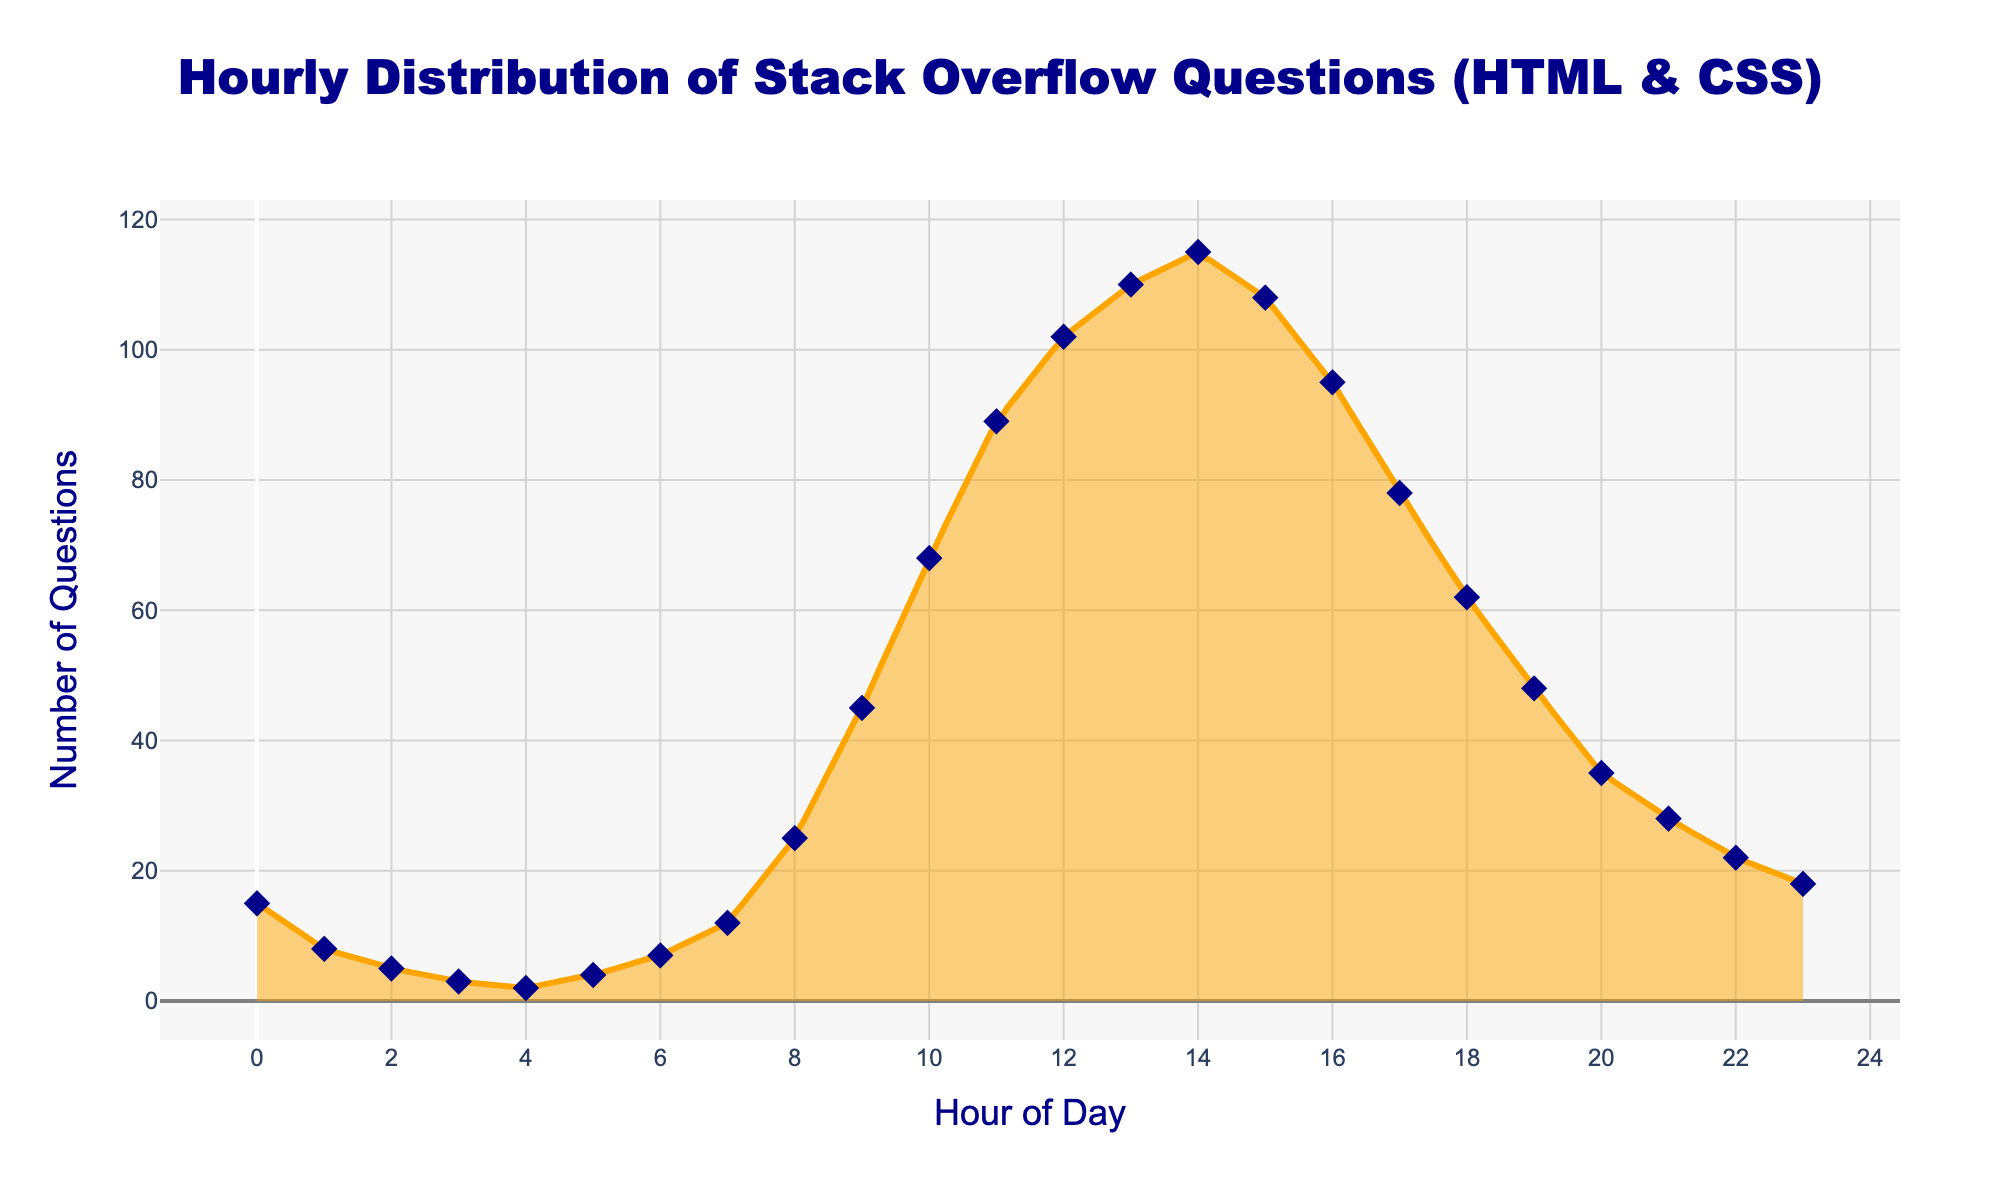What's the title of the plot? The title of the plot is displayed at the top of the figure. It reads "Hourly Distribution of Stack Overflow Questions (HTML & CSS)".
Answer: Hourly Distribution of Stack Overflow Questions (HTML & CSS) What does the x-axis represent? The x-axis label, located at the bottom of the figure, describes the variable it represents. It is labeled "Hour of Day".
Answer: Hour of Day What is the number of questions posted at 12 PM? Refer to the data points on the graph where the x-axis value is 12. The corresponding y-axis value gives the number of questions. At 12 PM, it is 102.
Answer: 102 What is the range of the y-axis? The y-axis values span from the minimum to the maximum data points represented in the plot. The lowest value is 0, and the highest value is just above 115.
Answer: 0 to 115 At what hour is the peak number of questions posted, and what is the count? The peak of the smooth density curve indicates the hour with the highest number of questions, and the corresponding y-axis value shows the count. The highest density occurs at hour 14 with a count of 115.
Answer: 14, 115 How many data points are visible on the plot? Each unique marker represents a data point. By counting the markers on the scatter plot, we find there are 24 data points, one for each hour.
Answer: 24 During which periods are the number of questions below 10? Observing the density plot and scatter points, we see values below 10 occur at hours 0-3, 4, 6, and 21-23.
Answer: 0-6, 21-23 Describe the general trend of question numbers from 8 AM to 3 PM. To understand the trend, note the progression of y-values on the density plot between the specified hours. The question numbers increase from 25 at 8 AM, reaching a peak of 115 at 2 PM, and then slightly drop to 108 at 3 PM.
Answer: Increasing, peaking, then slight drop Compare the number of questions posted at 5 AM and 5 PM. Which hour has more posts, and what are their counts? By checking the y-values of the scatter plot at 5 AM and 5 PM, we see the counts are 4 and 95, respectively.
Answer: 5 PM, 4 and 95 What color is used to fill the density plot? The fill color of the density plot gives a visual cue about its identity. It is an orange shade with some transparency.
Answer: Orange with transparency 